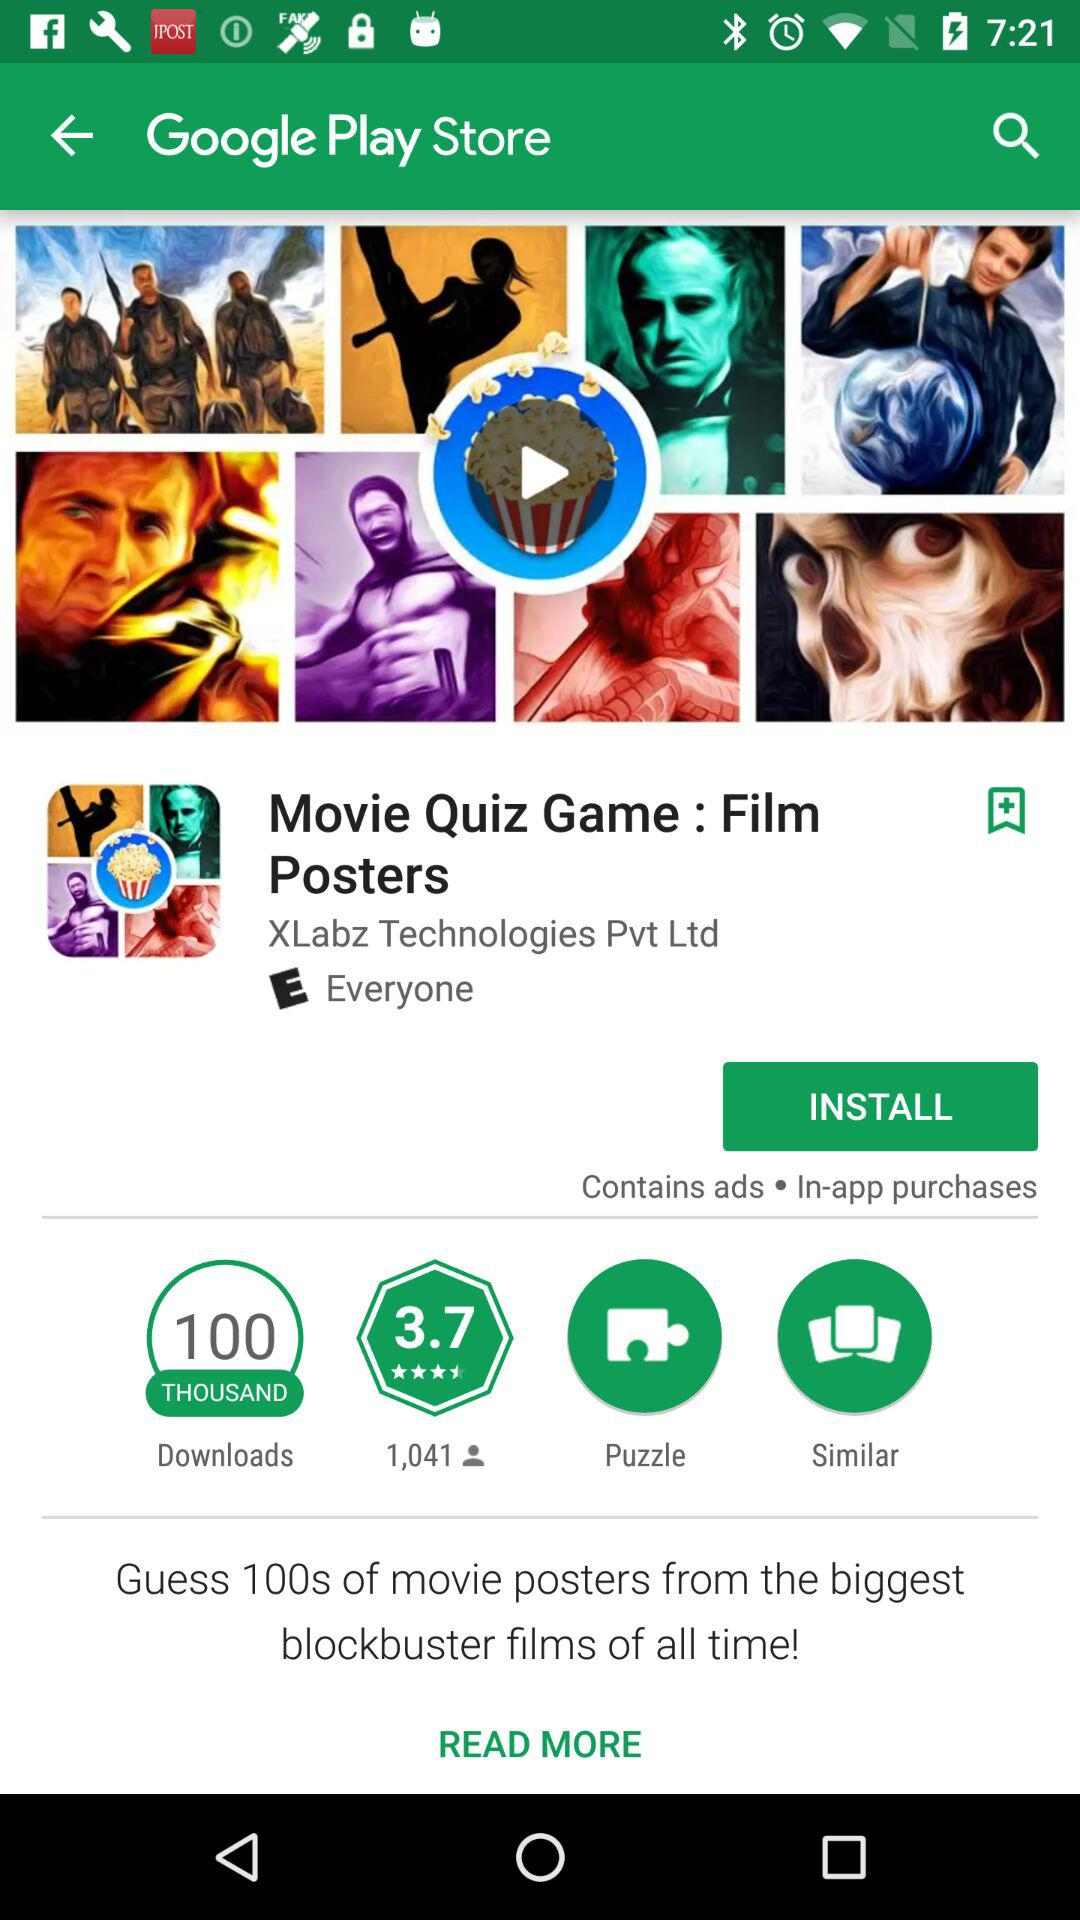Who designed the "Movie Quiz Game : Film Posters" application? The "Movie Quiz Game : Film Posters" application was designed by "XLabz Technologies Pvt Ltd". 